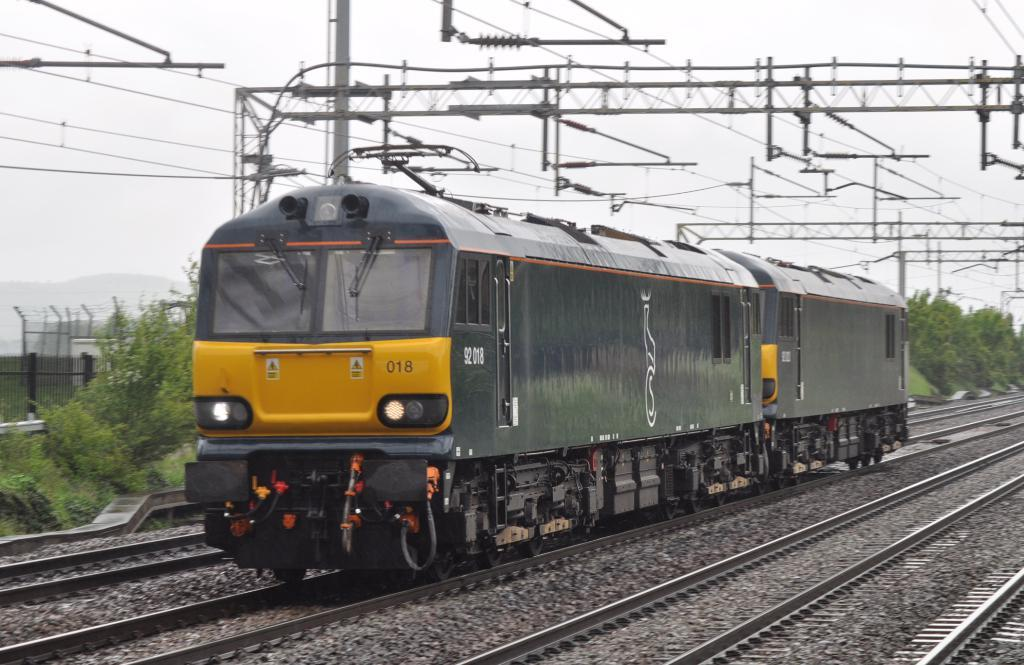<image>
Present a compact description of the photo's key features. A train has the number 018 on the front of it. 